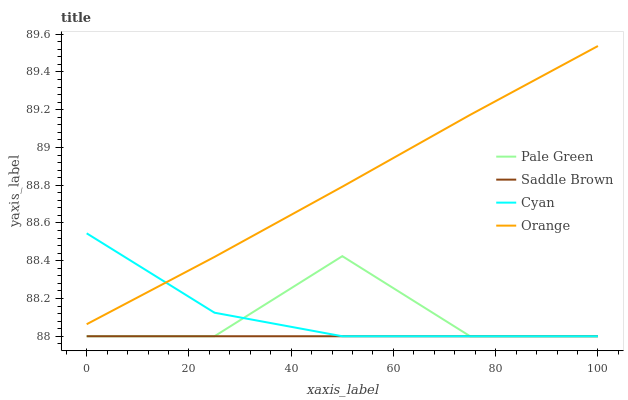Does Saddle Brown have the minimum area under the curve?
Answer yes or no. Yes. Does Orange have the maximum area under the curve?
Answer yes or no. Yes. Does Cyan have the minimum area under the curve?
Answer yes or no. No. Does Cyan have the maximum area under the curve?
Answer yes or no. No. Is Saddle Brown the smoothest?
Answer yes or no. Yes. Is Pale Green the roughest?
Answer yes or no. Yes. Is Cyan the smoothest?
Answer yes or no. No. Is Cyan the roughest?
Answer yes or no. No. Does Cyan have the highest value?
Answer yes or no. No. Is Pale Green less than Orange?
Answer yes or no. Yes. Is Orange greater than Pale Green?
Answer yes or no. Yes. Does Pale Green intersect Orange?
Answer yes or no. No. 